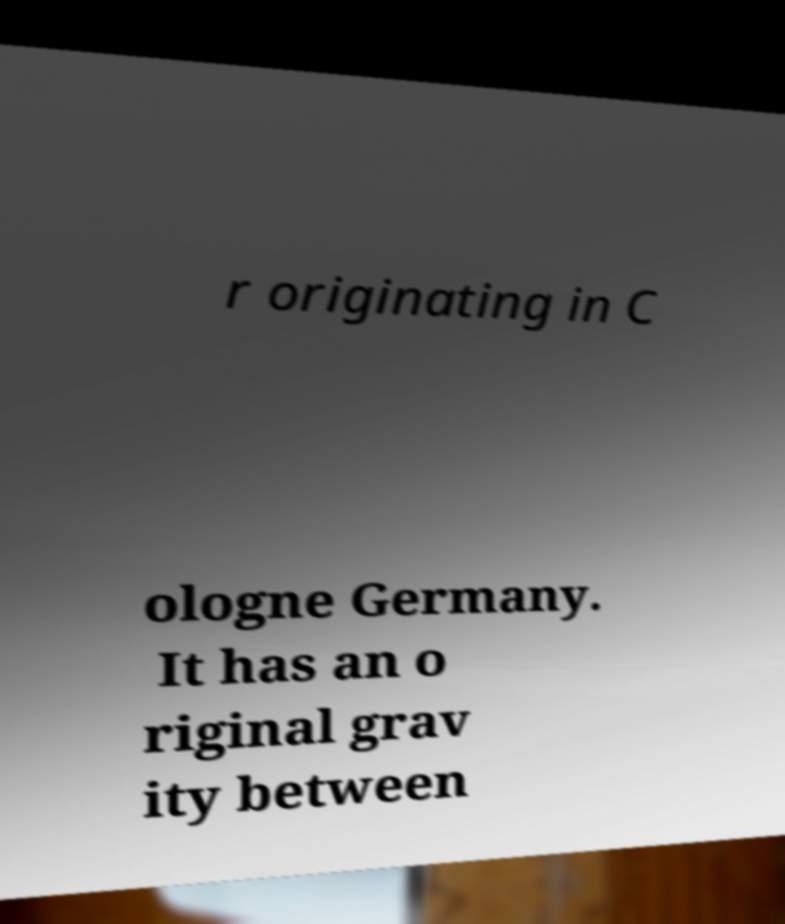Could you extract and type out the text from this image? r originating in C ologne Germany. It has an o riginal grav ity between 